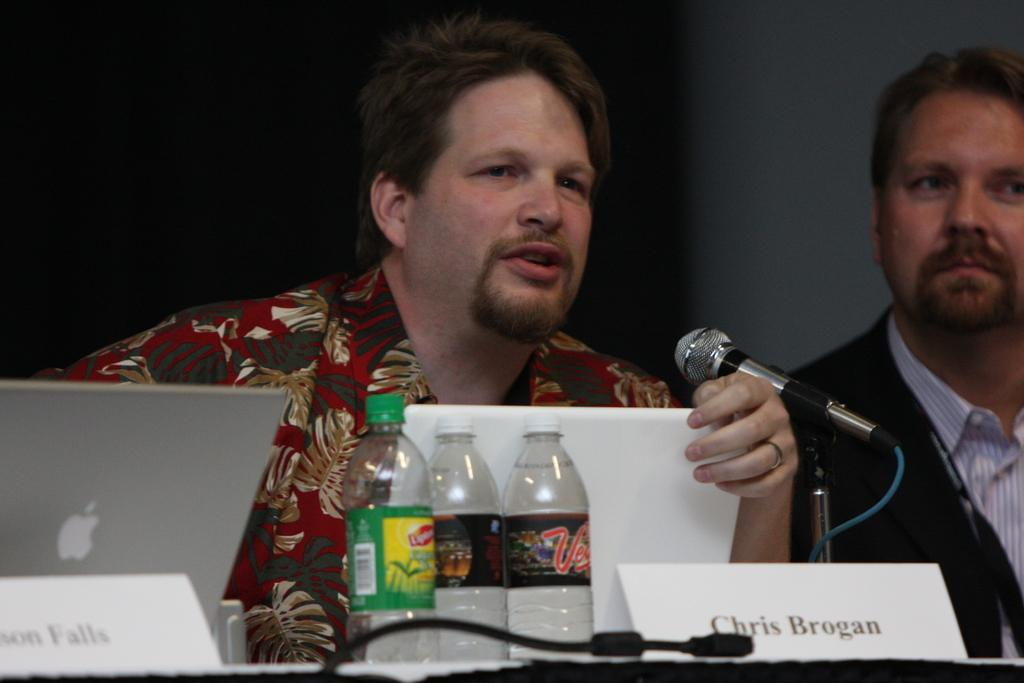What is the main subject in front of the table in the image? There is a person in front of the table in the image. What is on the table in the image? The table contains a laptop, bottles, and a mic. Can you describe the person on the right side of the image? The person on the right side of the image is wearing clothes. What type of grass can be seen growing on the desk in the image? There is no grass or desk present in the image. How many baskets are visible in the image? There are no baskets visible in the image. 